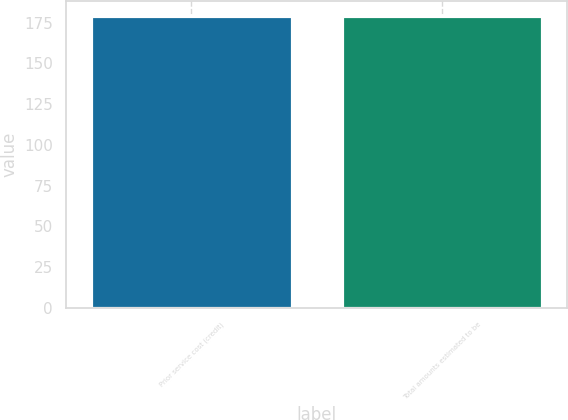<chart> <loc_0><loc_0><loc_500><loc_500><bar_chart><fcel>Prior service cost (credit)<fcel>Total amounts estimated to be<nl><fcel>179<fcel>179.1<nl></chart> 